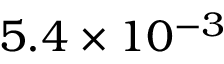Convert formula to latex. <formula><loc_0><loc_0><loc_500><loc_500>5 . 4 \times 1 0 ^ { - 3 }</formula> 